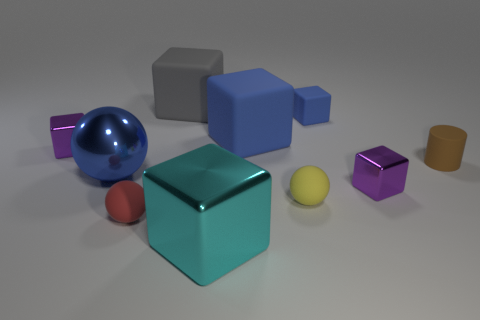Subtract 2 cubes. How many cubes are left? 4 Subtract all gray cubes. How many cubes are left? 5 Subtract all gray blocks. How many blocks are left? 5 Subtract all brown blocks. Subtract all purple balls. How many blocks are left? 6 Subtract all spheres. How many objects are left? 7 Subtract 0 red cubes. How many objects are left? 10 Subtract all small blue things. Subtract all gray matte objects. How many objects are left? 8 Add 7 small purple cubes. How many small purple cubes are left? 9 Add 1 big red spheres. How many big red spheres exist? 1 